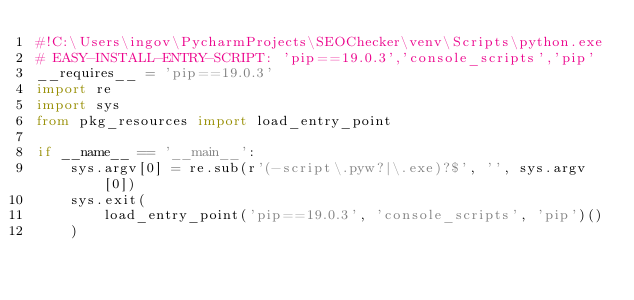Convert code to text. <code><loc_0><loc_0><loc_500><loc_500><_Python_>#!C:\Users\ingov\PycharmProjects\SEOChecker\venv\Scripts\python.exe
# EASY-INSTALL-ENTRY-SCRIPT: 'pip==19.0.3','console_scripts','pip'
__requires__ = 'pip==19.0.3'
import re
import sys
from pkg_resources import load_entry_point

if __name__ == '__main__':
    sys.argv[0] = re.sub(r'(-script\.pyw?|\.exe)?$', '', sys.argv[0])
    sys.exit(
        load_entry_point('pip==19.0.3', 'console_scripts', 'pip')()
    )
</code> 